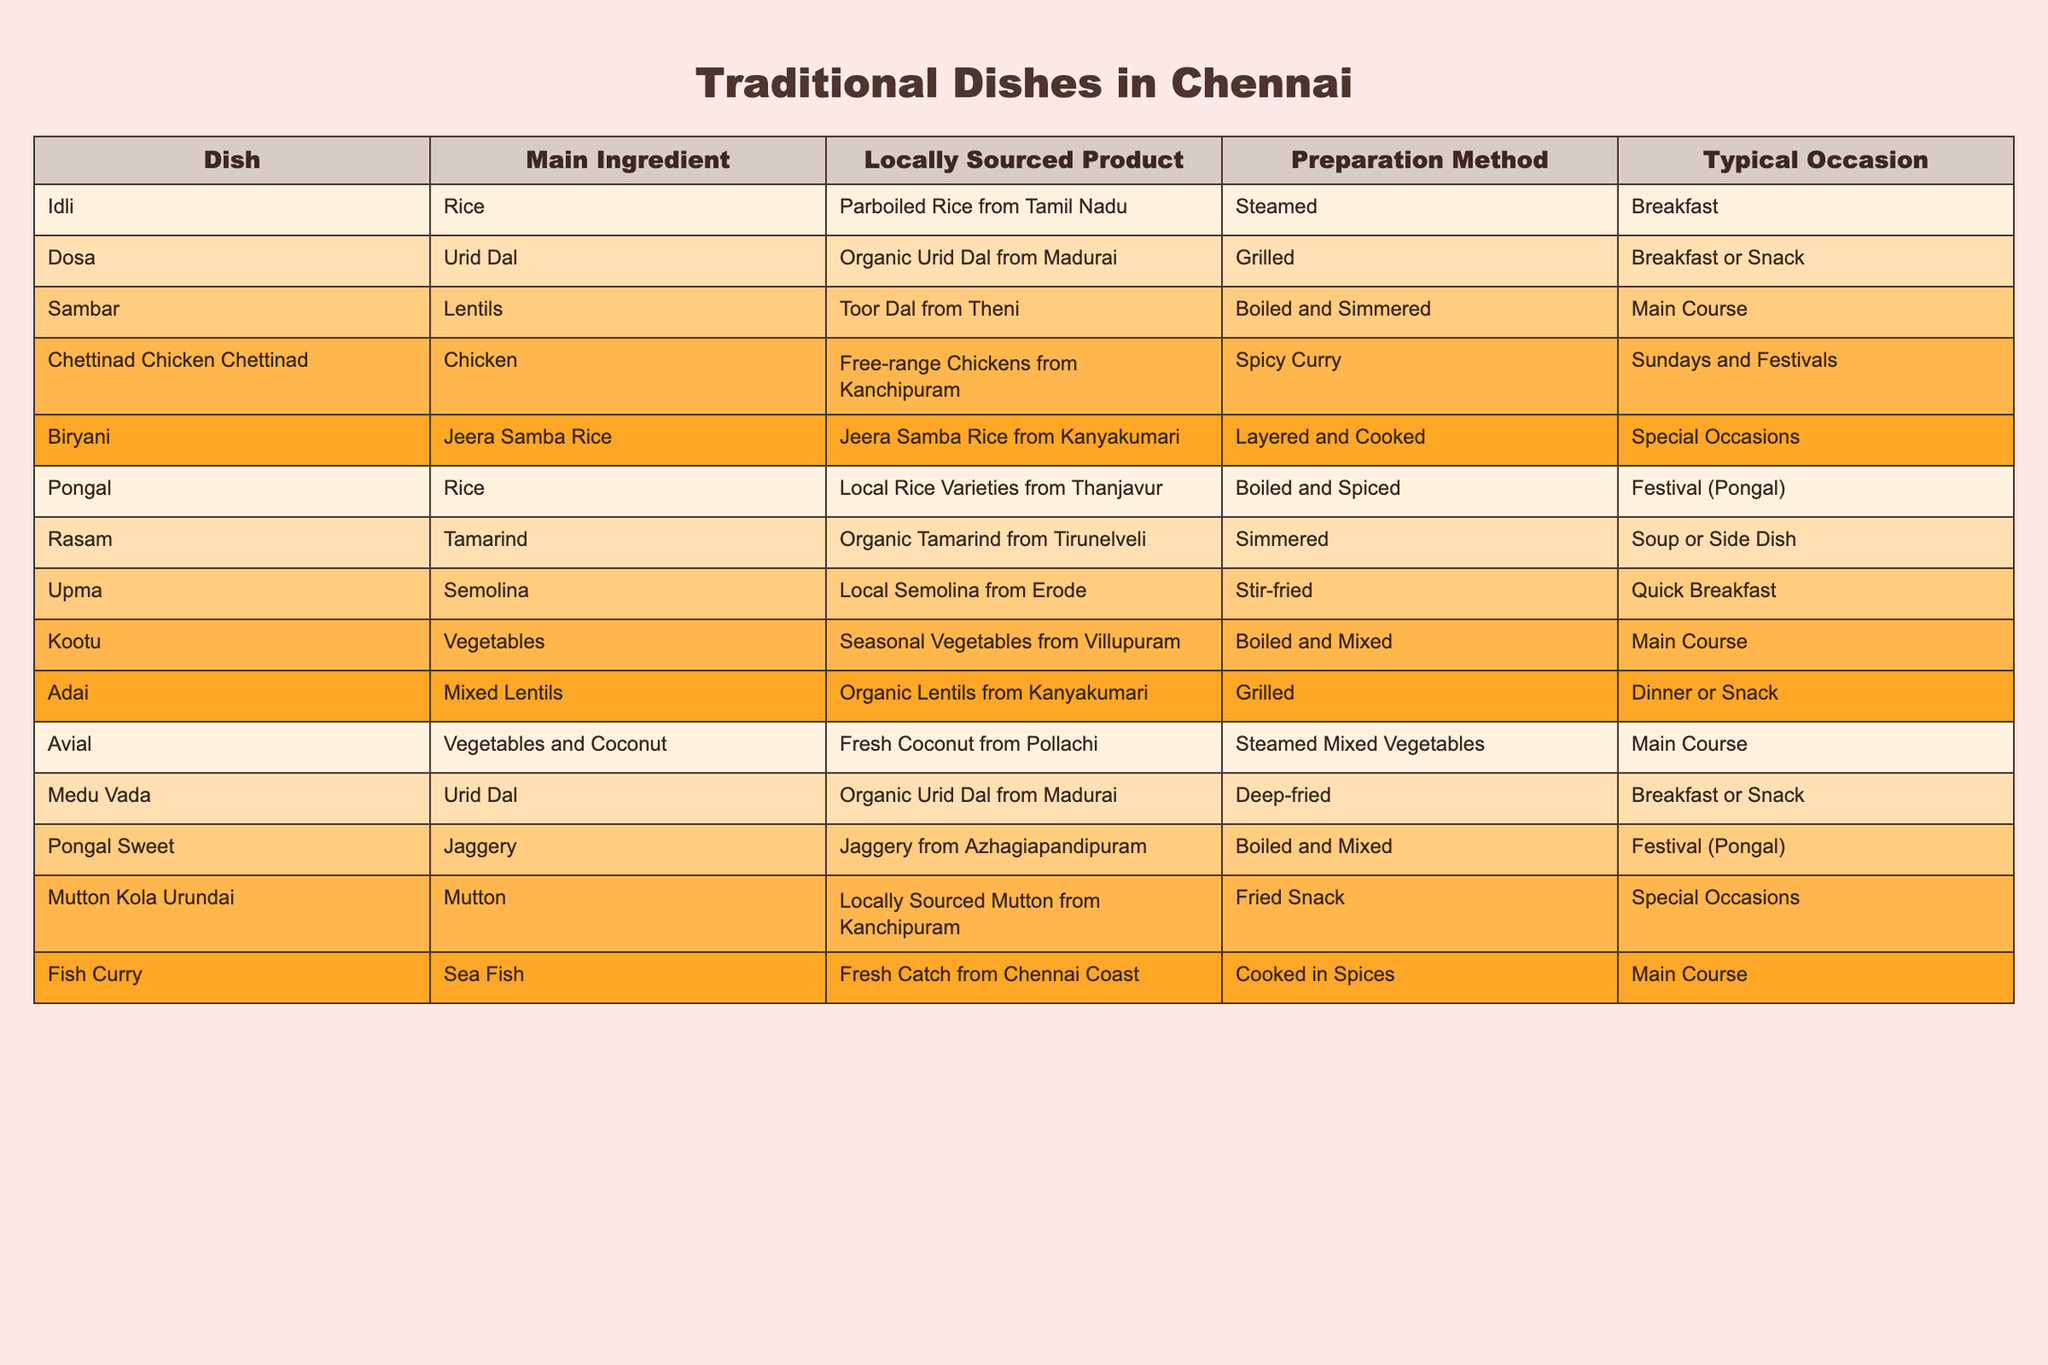What is the main ingredient used in Idli? The table shows that the main ingredient in Idli is Rice.
Answer: Rice Which traditional dish is associated with fresh coconut from Pollachi? According to the table, the dish that uses fresh coconut from Pollachi is Avial.
Answer: Avial How many dishes use Urid Dal as their main ingredient? The table lists two dishes that use Urid Dal as the main ingredient: Dosa and Medu Vada.
Answer: 2 What is the preparation method for Dosa? The table states that Dosa is prepared by grilling.
Answer: Grilled Is Sambar considered a breakfast dish? From the table, Sambar is listed under the main course section, indicating it is not typically considered a breakfast dish.
Answer: No Which dish is prepared using local rice varieties from Thanjavur? The table specifies that Pongal is prepared using local rice varieties from Thanjavur.
Answer: Pongal What dish is served on the occasion of festivals, specifically Pongal? The table mentions two dishes served during Pongal: Pongal and Pongal Sweet.
Answer: Pongal and Pongal Sweet How many main course dishes are listed in the table? By counting the entries, we find that there are four dishes listed under the main course: Sambar, Kootu, Avial, and Fish Curry.
Answer: 4 Which dish is made from Jeera Samba Rice from Kanyakumari? The dish made from Jeera Samba Rice from Kanyakumari, as stated in the table, is Biryani.
Answer: Biryani Do all the dishes listed have locally sourced ingredients? The table indicates that all dishes feature locally sourced ingredients, making the statement true.
Answer: Yes What is the difference in preparation methods between Idli and Upma? Idli is prepared by steaming, while Upma is stir-fried, as observed in the preparation methods section of the table.
Answer: Steamed (Idli), Stir-fried (Upma) How many dishes are prepared using boiling as the preparation method? Looking at the table, three dishes are prepared using boiling: Sambar, Pongal, and Pongal Sweet.
Answer: 3 Which dish is specifically marked for Sundays and festivals? The table indicates that Chettinad Chicken Chettinad is specifically prepared on Sundays and festivals.
Answer: Chettinad Chicken Chettinad Which ingredient is common in both Kootu and Avial? The table shows that both Kootu and Avial use vegetables as a common ingredient.
Answer: Vegetables What is the main ingredient in the dish made from seasonal vegetables from Villupuram? The dish made from seasonal vegetables from Villupuram, as stated in the table, is Kootu, with the main ingredient being vegetables.
Answer: Kootu (Vegetables) 